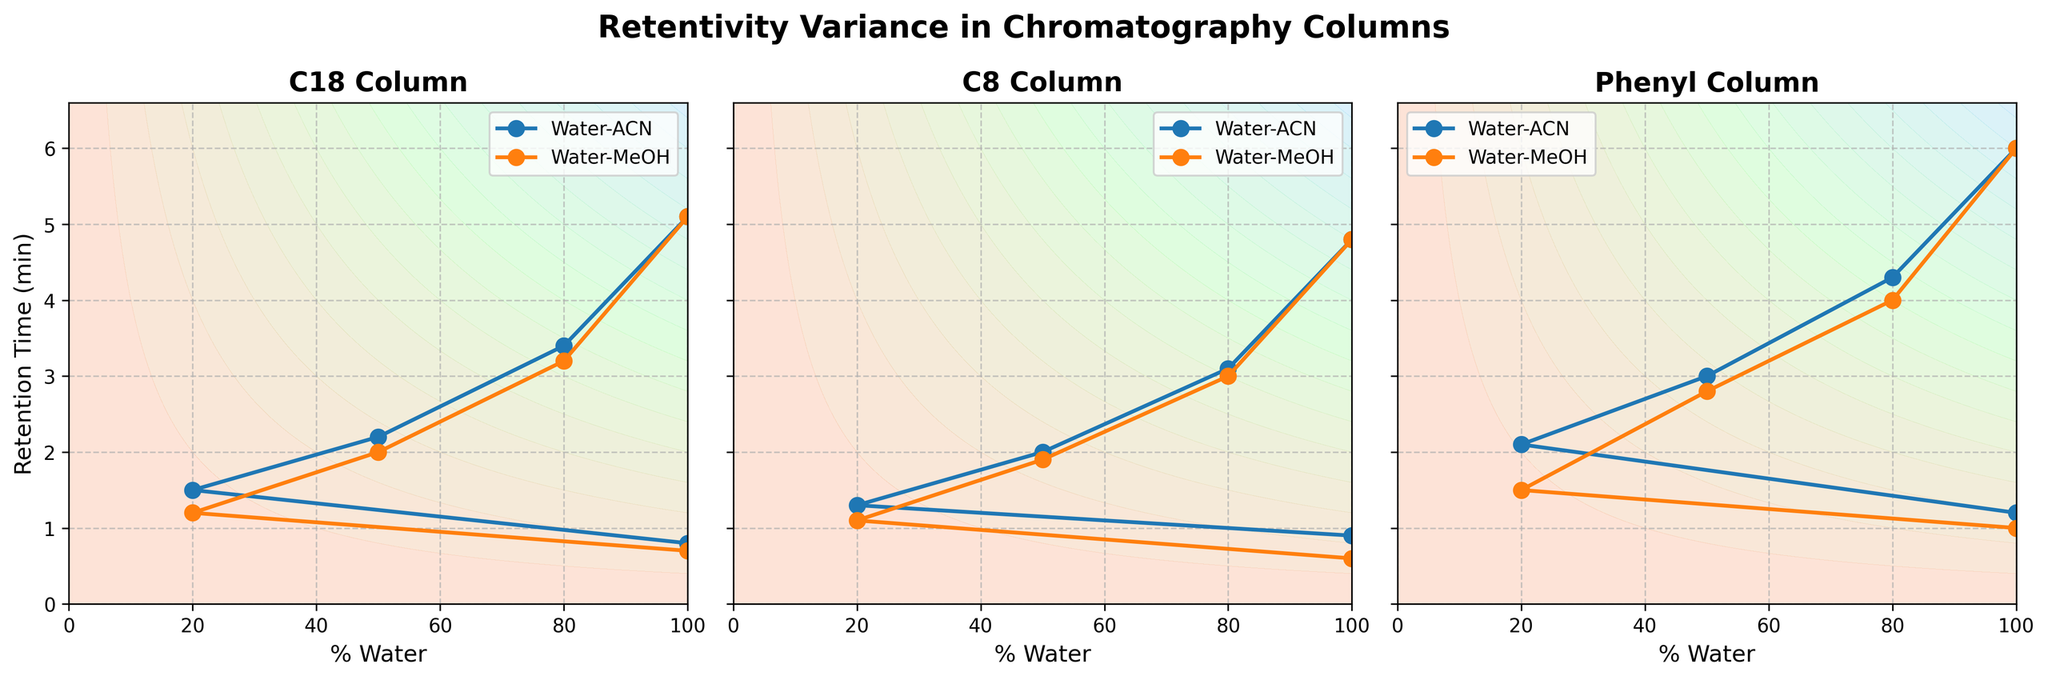How many subplots are there in the figure? There are three columns, each represented in a separate subplot. So, there are three subplots in the figure.
Answer: 3 What chromatography column has the highest retention time with pure water? By looking at the retention times with 'Water' for each column, the Phenyl column has the highest retention time.
Answer: Phenyl Does the retention time consistently decrease as the percentage of water decreases across all columns? Yes, in each subplot, as we move from 100% water to lower percentages (80-20, 50-50, 20-80) and finally 100% of the organic solvent (ACN or MeOH), the retention time decreases consistently.
Answer: Yes Which chromatography column shows the largest variability in retention time across all solvent compositions? The Phenyl column shows the largest range of retention time values, from 6.0 minutes with pure water to 1.0 minute with pure methanol.
Answer: Phenyl Compare the retention times of C18 and C8 columns with 50-50 Water-ACN composition. Which one has a higher retention time? For 50-50 Water-ACN composition, C18 has a retention time of 2.2 minutes, while C8 has a retention time of 2.0 minutes. Therefore, C18 has a higher retention time.
Answer: C18 Between Water-ACN and Water-MeOH, which solvent shows a generally faster decrease in retention times as the percentage of organic solvent increases? By observing the slopes of the retention times, the retention times decrease more sharply with Water-ACN compared to Water-MeOH across all columns in the plots.
Answer: Water-ACN What trend is observed in retention times from 100% Water to 100% Methanol in the C8 column? The trend shows a consistent decrease in retention time as the composition moves from 100% Water to 100% Methanol, starting at 4.8 minutes and ending at 0.6 minutes.
Answer: Decrease In the C18 column, which solvent composition has the closest retention time to 2 minutes? For the C18 column, the Water-MeOH 50-50 composition has a retention time closest to 2 minutes, with a recorded time of exactly 2.0 minutes.
Answer: Water-MeOH 50-50 Which column shows the least difference in retention times between 100% ACN and 100% MeOH? The C8 column shows the least difference between 100% ACN (0.9 minutes) and 100% MeOH (0.6 minutes), with a difference of 0.3 minutes.
Answer: C8 